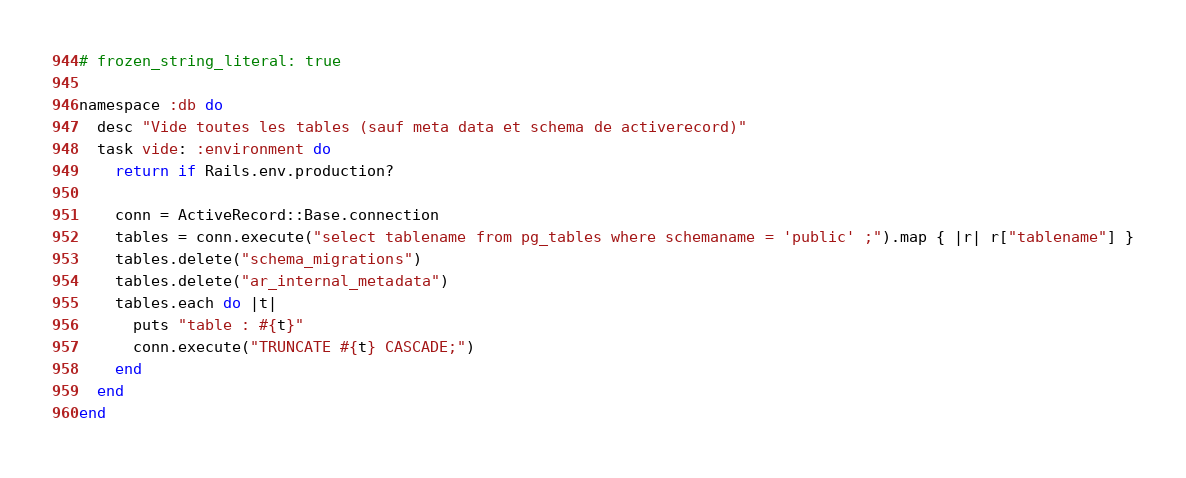<code> <loc_0><loc_0><loc_500><loc_500><_Ruby_># frozen_string_literal: true

namespace :db do
  desc "Vide toutes les tables (sauf meta data et schema de activerecord)"
  task vide: :environment do
    return if Rails.env.production?

    conn = ActiveRecord::Base.connection
    tables = conn.execute("select tablename from pg_tables where schemaname = 'public' ;").map { |r| r["tablename"] }
    tables.delete("schema_migrations")
    tables.delete("ar_internal_metadata")
    tables.each do |t|
      puts "table : #{t}"
      conn.execute("TRUNCATE #{t} CASCADE;")
    end
  end
end
</code> 